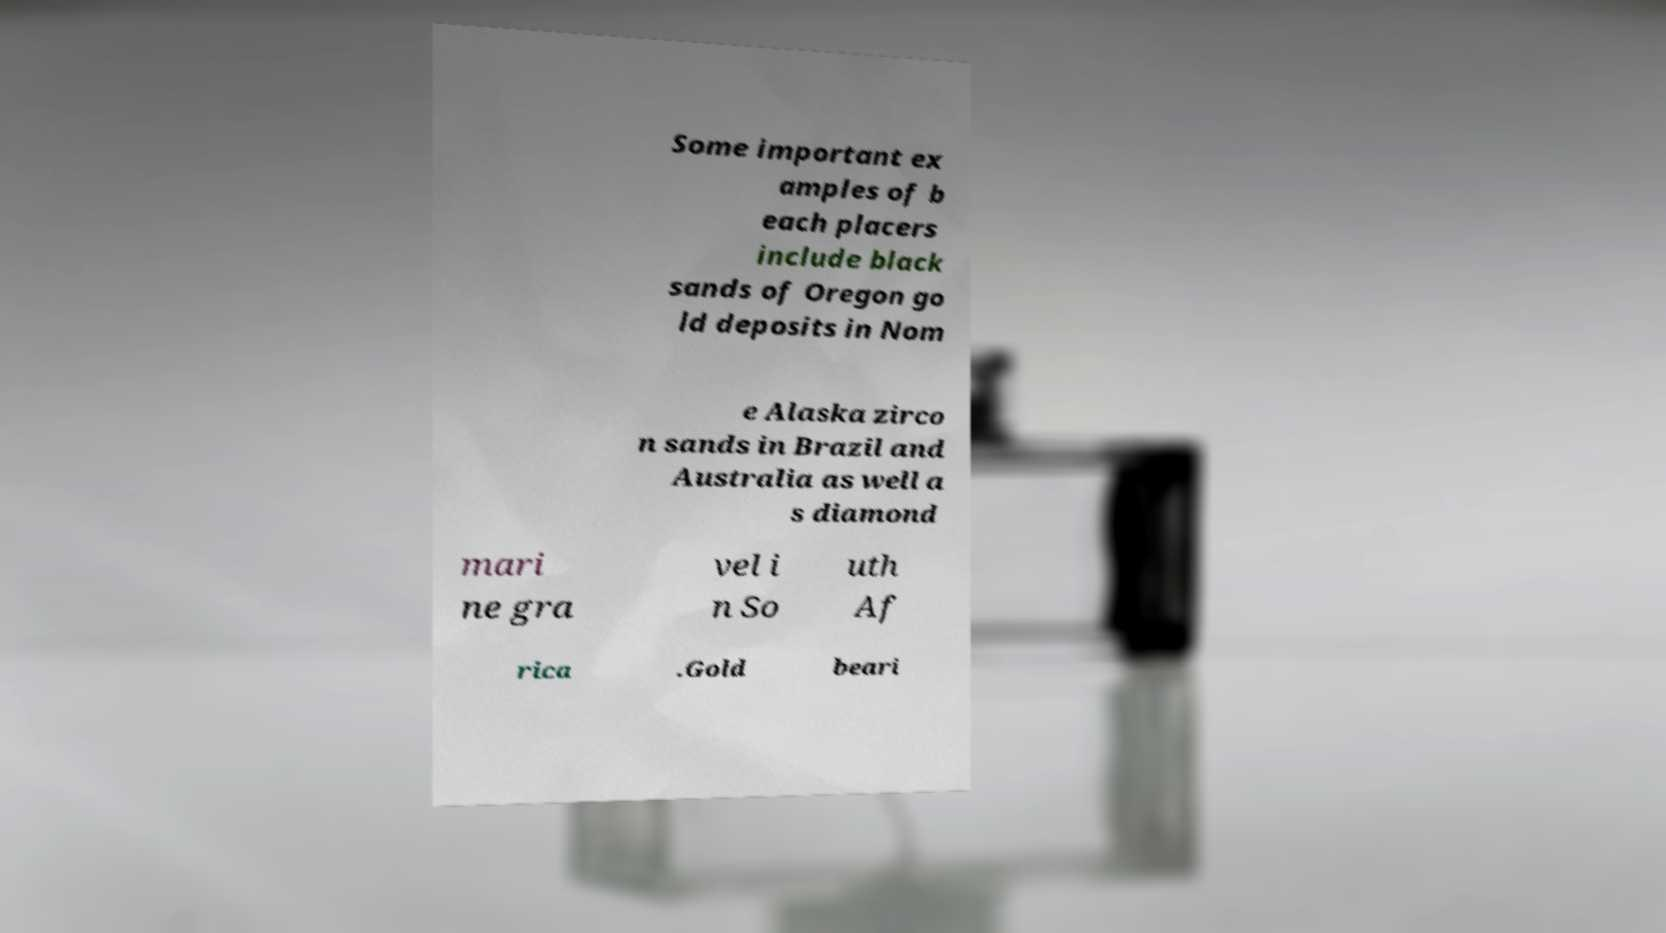What messages or text are displayed in this image? I need them in a readable, typed format. Some important ex amples of b each placers include black sands of Oregon go ld deposits in Nom e Alaska zirco n sands in Brazil and Australia as well a s diamond mari ne gra vel i n So uth Af rica .Gold beari 